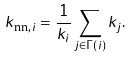<formula> <loc_0><loc_0><loc_500><loc_500>k _ { \text {nn} , i } = \frac { 1 } { k _ { i } } \sum _ { j \in \Gamma ( i ) } k _ { j } .</formula> 